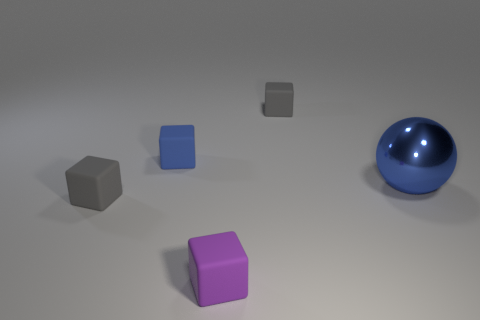Is there anything else that is the same size as the blue metal thing?
Your response must be concise. No. Are there any cubes that have the same color as the big metal sphere?
Your answer should be very brief. Yes. Are there more gray cubes on the left side of the purple block than big gray things?
Offer a terse response. Yes. There is a blue matte object; does it have the same shape as the gray object that is in front of the tiny blue rubber block?
Provide a succinct answer. Yes. How many other gray things are the same size as the shiny object?
Your response must be concise. 0. What number of tiny blue rubber blocks are behind the gray rubber object to the right of the gray matte block that is on the left side of the small purple block?
Your response must be concise. 0. Are there an equal number of cubes on the right side of the big blue shiny ball and blue metallic spheres that are behind the small blue matte block?
Offer a very short reply. Yes. What number of other tiny objects have the same shape as the blue matte object?
Make the answer very short. 3. Is there a blue cube that has the same material as the tiny purple object?
Provide a succinct answer. Yes. There is another thing that is the same color as the shiny thing; what is its shape?
Your answer should be very brief. Cube. 